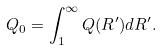<formula> <loc_0><loc_0><loc_500><loc_500>Q _ { 0 } = \int _ { 1 } ^ { \infty } Q ( R ^ { \prime } ) d R ^ { \prime } .</formula> 